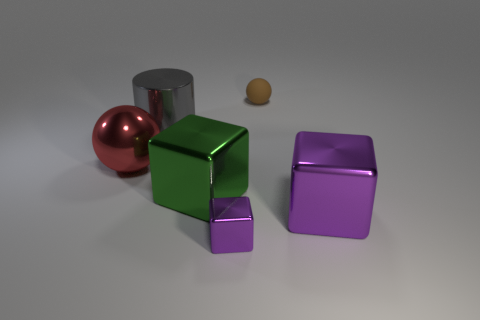Can you describe the texture of the objects and what that might imply about their physical feel? The objects display different textures; the cubes and cylinder have smooth, almost mirror-like surfaces that imply a cool and hard physical feel. In contrast, the rubber object appears matt and slightly textured, suggesting a softer and more tactile surface that might offer some grip. 